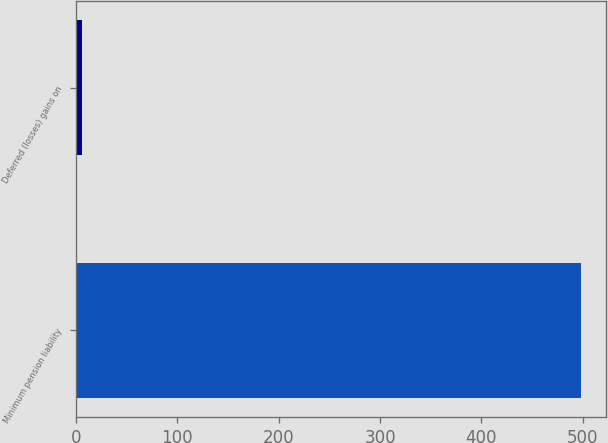<chart> <loc_0><loc_0><loc_500><loc_500><bar_chart><fcel>Minimum pension liability<fcel>Deferred (losses) gains on<nl><fcel>498.3<fcel>5.7<nl></chart> 